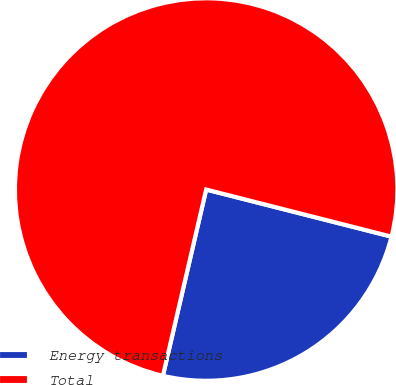<chart> <loc_0><loc_0><loc_500><loc_500><pie_chart><fcel>Energy transactions<fcel>Total<nl><fcel>24.67%<fcel>75.33%<nl></chart> 